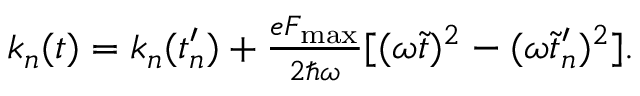<formula> <loc_0><loc_0><loc_500><loc_500>\begin{array} { r } { k _ { n } ( t ) = k _ { n } ( t _ { n } ^ { \prime } ) + \frac { e F _ { \max } } { 2 \hbar { \omega } } [ ( \omega \tilde { t } ) ^ { 2 } - ( \omega \tilde { t } _ { n } ^ { \prime } ) ^ { 2 } ] . } \end{array}</formula> 